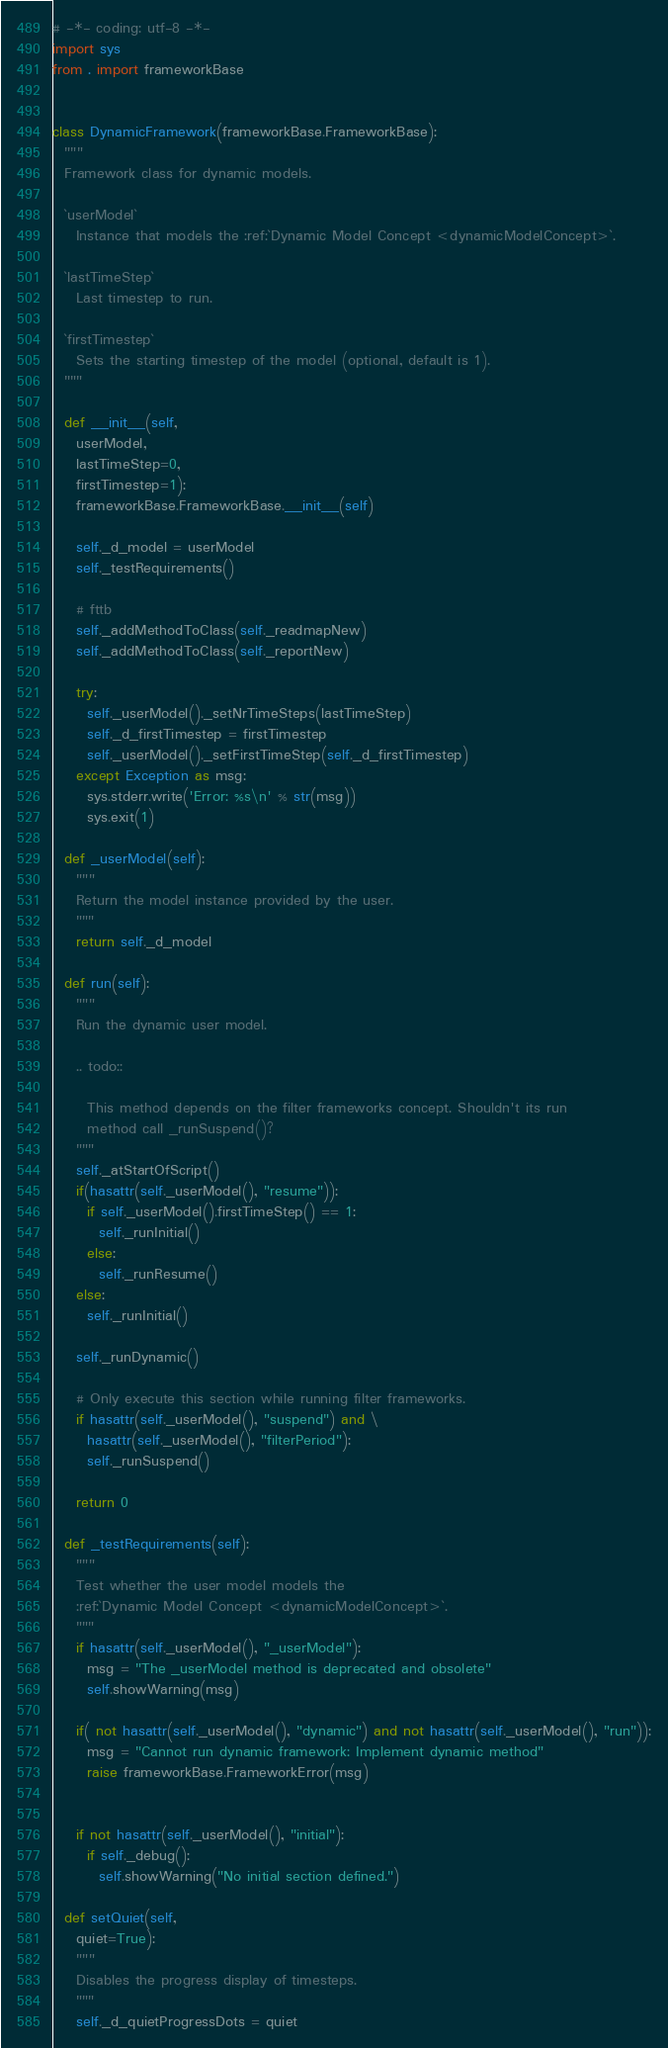Convert code to text. <code><loc_0><loc_0><loc_500><loc_500><_Python_># -*- coding: utf-8 -*-
import sys
from . import frameworkBase


class DynamicFramework(frameworkBase.FrameworkBase):
  """
  Framework class for dynamic models.

  `userModel`
    Instance that models the :ref:`Dynamic Model Concept <dynamicModelConcept>`.

  `lastTimeStep`
    Last timestep to run.

  `firstTimestep`
    Sets the starting timestep of the model (optional, default is 1).
  """

  def __init__(self,
    userModel,
    lastTimeStep=0,
    firstTimestep=1):
    frameworkBase.FrameworkBase.__init__(self)

    self._d_model = userModel
    self._testRequirements()

    # fttb
    self._addMethodToClass(self._readmapNew)
    self._addMethodToClass(self._reportNew)

    try:
      self._userModel()._setNrTimeSteps(lastTimeStep)
      self._d_firstTimestep = firstTimestep
      self._userModel()._setFirstTimeStep(self._d_firstTimestep)
    except Exception as msg:
      sys.stderr.write('Error: %s\n' % str(msg))
      sys.exit(1)

  def _userModel(self):
    """
    Return the model instance provided by the user.
    """
    return self._d_model

  def run(self):
    """
    Run the dynamic user model.

    .. todo::

      This method depends on the filter frameworks concept. Shouldn't its run
      method call _runSuspend()?
    """
    self._atStartOfScript()
    if(hasattr(self._userModel(), "resume")):
      if self._userModel().firstTimeStep() == 1:
        self._runInitial()
      else:
        self._runResume()
    else:
      self._runInitial()

    self._runDynamic()

    # Only execute this section while running filter frameworks.
    if hasattr(self._userModel(), "suspend") and \
      hasattr(self._userModel(), "filterPeriod"):
      self._runSuspend()

    return 0

  def _testRequirements(self):
    """
    Test whether the user model models the
    :ref:`Dynamic Model Concept <dynamicModelConcept>`.
    """
    if hasattr(self._userModel(), "_userModel"):
      msg = "The _userModel method is deprecated and obsolete"
      self.showWarning(msg)

    if( not hasattr(self._userModel(), "dynamic") and not hasattr(self._userModel(), "run")):
      msg = "Cannot run dynamic framework: Implement dynamic method"
      raise frameworkBase.FrameworkError(msg)


    if not hasattr(self._userModel(), "initial"):
      if self._debug():
        self.showWarning("No initial section defined.")

  def setQuiet(self,
    quiet=True):
    """
    Disables the progress display of timesteps.
    """
    self._d_quietProgressDots = quiet

</code> 